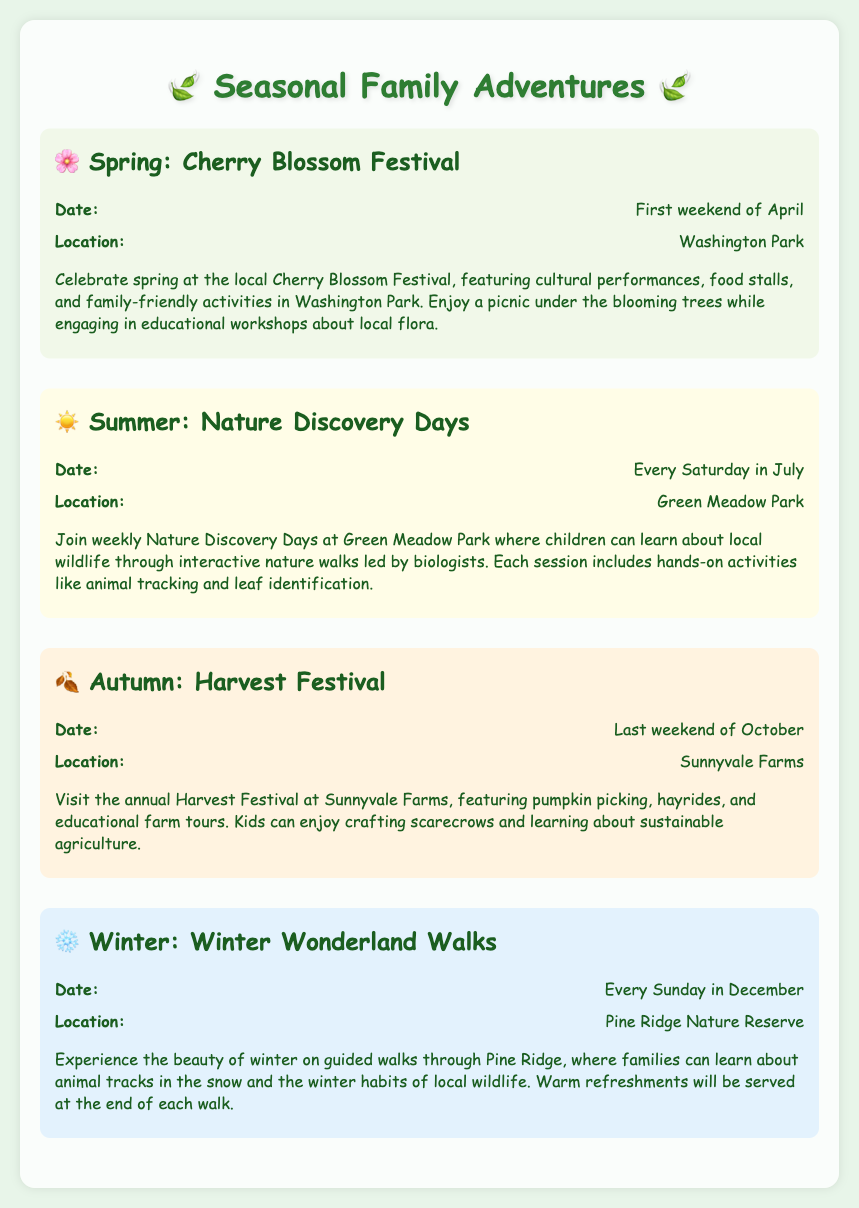What is the date of the Cherry Blossom Festival? The Cherry Blossom Festival is scheduled for the first weekend of April, as stated in the document.
Answer: First weekend of April Where is the Nature Discovery Days event located? The Nature Discovery Days event takes place at Green Meadow Park, according to the information provided.
Answer: Green Meadow Park What activities can children participate in at the Harvest Festival? The document mentions that children can enjoy pumpkin picking, hayrides, and crafting scarecrows during the Harvest Festival.
Answer: Pumpkin picking, hayrides, crafting scarecrows What kind of workshop is available at the Cherry Blossom Festival? The Cherry Blossom Festival includes educational workshops about local flora, which is mentioned in the description of the event.
Answer: Workshops about local flora Which park hosts the Winter Wonderland Walks? The Winter Wonderland Walks are held at Pine Ridge Nature Reserve, as indicated in the event description.
Answer: Pine Ridge Nature Reserve How often do Winter Wonderland Walks occur? The document specifies that Winter Wonderland Walks occur every Sunday in December.
Answer: Every Sunday in December What is the main theme of Nature Discovery Days? The main theme of Nature Discovery Days is learning about local wildlife through interactive nature walks.
Answer: Local wildlife When does the Harvest Festival take place? According to the document, the Harvest Festival is held on the last weekend of October.
Answer: Last weekend of October 